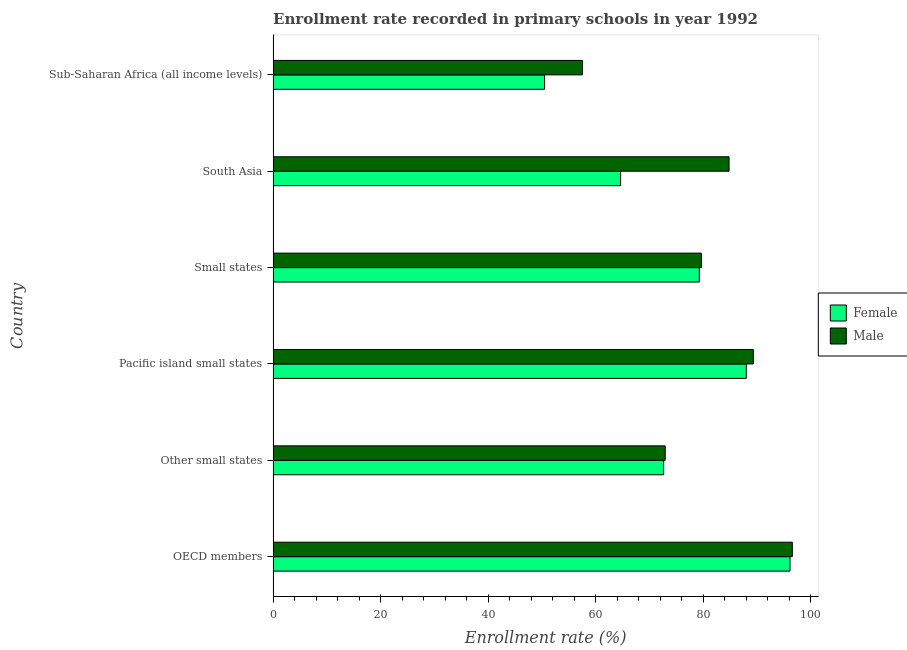How many groups of bars are there?
Your response must be concise. 6. Are the number of bars per tick equal to the number of legend labels?
Keep it short and to the point. Yes. What is the label of the 4th group of bars from the top?
Your answer should be compact. Pacific island small states. In how many cases, is the number of bars for a given country not equal to the number of legend labels?
Give a very brief answer. 0. What is the enrollment rate of female students in Small states?
Offer a terse response. 79.31. Across all countries, what is the maximum enrollment rate of female students?
Your answer should be very brief. 96.19. Across all countries, what is the minimum enrollment rate of female students?
Provide a succinct answer. 50.52. In which country was the enrollment rate of male students minimum?
Ensure brevity in your answer.  Sub-Saharan Africa (all income levels). What is the total enrollment rate of female students in the graph?
Provide a short and direct response. 451.41. What is the difference between the enrollment rate of male students in South Asia and that in Sub-Saharan Africa (all income levels)?
Provide a short and direct response. 27.3. What is the difference between the enrollment rate of female students in Pacific island small states and the enrollment rate of male students in Sub-Saharan Africa (all income levels)?
Your answer should be very brief. 30.5. What is the average enrollment rate of female students per country?
Provide a succinct answer. 75.23. What is the difference between the enrollment rate of female students and enrollment rate of male students in Sub-Saharan Africa (all income levels)?
Provide a succinct answer. -7.03. What is the ratio of the enrollment rate of female students in South Asia to that in Sub-Saharan Africa (all income levels)?
Provide a short and direct response. 1.28. Is the difference between the enrollment rate of male students in OECD members and Small states greater than the difference between the enrollment rate of female students in OECD members and Small states?
Offer a very short reply. Yes. What is the difference between the highest and the second highest enrollment rate of male students?
Make the answer very short. 7.26. What is the difference between the highest and the lowest enrollment rate of male students?
Provide a short and direct response. 39.07. In how many countries, is the enrollment rate of male students greater than the average enrollment rate of male students taken over all countries?
Your answer should be compact. 3. What does the 1st bar from the top in Pacific island small states represents?
Keep it short and to the point. Male. How many bars are there?
Your answer should be very brief. 12. How many countries are there in the graph?
Provide a short and direct response. 6. Are the values on the major ticks of X-axis written in scientific E-notation?
Your answer should be very brief. No. Does the graph contain any zero values?
Offer a very short reply. No. Where does the legend appear in the graph?
Your response must be concise. Center right. How are the legend labels stacked?
Keep it short and to the point. Vertical. What is the title of the graph?
Ensure brevity in your answer.  Enrollment rate recorded in primary schools in year 1992. What is the label or title of the X-axis?
Ensure brevity in your answer.  Enrollment rate (%). What is the Enrollment rate (%) in Female in OECD members?
Your response must be concise. 96.19. What is the Enrollment rate (%) in Male in OECD members?
Your answer should be compact. 96.62. What is the Enrollment rate (%) of Female in Other small states?
Your response must be concise. 72.68. What is the Enrollment rate (%) in Male in Other small states?
Your response must be concise. 72.96. What is the Enrollment rate (%) in Female in Pacific island small states?
Your response must be concise. 88.05. What is the Enrollment rate (%) of Male in Pacific island small states?
Offer a very short reply. 89.36. What is the Enrollment rate (%) in Female in Small states?
Give a very brief answer. 79.31. What is the Enrollment rate (%) of Male in Small states?
Ensure brevity in your answer.  79.7. What is the Enrollment rate (%) in Female in South Asia?
Your response must be concise. 64.66. What is the Enrollment rate (%) of Male in South Asia?
Your answer should be compact. 84.85. What is the Enrollment rate (%) in Female in Sub-Saharan Africa (all income levels)?
Give a very brief answer. 50.52. What is the Enrollment rate (%) of Male in Sub-Saharan Africa (all income levels)?
Ensure brevity in your answer.  57.55. Across all countries, what is the maximum Enrollment rate (%) of Female?
Offer a very short reply. 96.19. Across all countries, what is the maximum Enrollment rate (%) of Male?
Give a very brief answer. 96.62. Across all countries, what is the minimum Enrollment rate (%) of Female?
Offer a terse response. 50.52. Across all countries, what is the minimum Enrollment rate (%) in Male?
Keep it short and to the point. 57.55. What is the total Enrollment rate (%) in Female in the graph?
Offer a terse response. 451.41. What is the total Enrollment rate (%) of Male in the graph?
Provide a short and direct response. 481.04. What is the difference between the Enrollment rate (%) in Female in OECD members and that in Other small states?
Your answer should be very brief. 23.51. What is the difference between the Enrollment rate (%) of Male in OECD members and that in Other small states?
Keep it short and to the point. 23.66. What is the difference between the Enrollment rate (%) in Female in OECD members and that in Pacific island small states?
Ensure brevity in your answer.  8.13. What is the difference between the Enrollment rate (%) in Male in OECD members and that in Pacific island small states?
Give a very brief answer. 7.26. What is the difference between the Enrollment rate (%) in Female in OECD members and that in Small states?
Provide a short and direct response. 16.88. What is the difference between the Enrollment rate (%) of Male in OECD members and that in Small states?
Provide a short and direct response. 16.92. What is the difference between the Enrollment rate (%) in Female in OECD members and that in South Asia?
Give a very brief answer. 31.52. What is the difference between the Enrollment rate (%) in Male in OECD members and that in South Asia?
Offer a very short reply. 11.78. What is the difference between the Enrollment rate (%) in Female in OECD members and that in Sub-Saharan Africa (all income levels)?
Provide a succinct answer. 45.67. What is the difference between the Enrollment rate (%) of Male in OECD members and that in Sub-Saharan Africa (all income levels)?
Your response must be concise. 39.07. What is the difference between the Enrollment rate (%) of Female in Other small states and that in Pacific island small states?
Offer a very short reply. -15.37. What is the difference between the Enrollment rate (%) in Male in Other small states and that in Pacific island small states?
Provide a succinct answer. -16.4. What is the difference between the Enrollment rate (%) in Female in Other small states and that in Small states?
Ensure brevity in your answer.  -6.63. What is the difference between the Enrollment rate (%) of Male in Other small states and that in Small states?
Provide a short and direct response. -6.74. What is the difference between the Enrollment rate (%) in Female in Other small states and that in South Asia?
Offer a terse response. 8.02. What is the difference between the Enrollment rate (%) in Male in Other small states and that in South Asia?
Your answer should be very brief. -11.88. What is the difference between the Enrollment rate (%) in Female in Other small states and that in Sub-Saharan Africa (all income levels)?
Keep it short and to the point. 22.16. What is the difference between the Enrollment rate (%) of Male in Other small states and that in Sub-Saharan Africa (all income levels)?
Your response must be concise. 15.42. What is the difference between the Enrollment rate (%) of Female in Pacific island small states and that in Small states?
Give a very brief answer. 8.75. What is the difference between the Enrollment rate (%) of Male in Pacific island small states and that in Small states?
Provide a short and direct response. 9.66. What is the difference between the Enrollment rate (%) in Female in Pacific island small states and that in South Asia?
Your response must be concise. 23.39. What is the difference between the Enrollment rate (%) of Male in Pacific island small states and that in South Asia?
Your answer should be very brief. 4.52. What is the difference between the Enrollment rate (%) in Female in Pacific island small states and that in Sub-Saharan Africa (all income levels)?
Offer a terse response. 37.54. What is the difference between the Enrollment rate (%) of Male in Pacific island small states and that in Sub-Saharan Africa (all income levels)?
Keep it short and to the point. 31.82. What is the difference between the Enrollment rate (%) of Female in Small states and that in South Asia?
Provide a succinct answer. 14.64. What is the difference between the Enrollment rate (%) of Male in Small states and that in South Asia?
Ensure brevity in your answer.  -5.15. What is the difference between the Enrollment rate (%) in Female in Small states and that in Sub-Saharan Africa (all income levels)?
Your answer should be very brief. 28.79. What is the difference between the Enrollment rate (%) of Male in Small states and that in Sub-Saharan Africa (all income levels)?
Your answer should be compact. 22.15. What is the difference between the Enrollment rate (%) in Female in South Asia and that in Sub-Saharan Africa (all income levels)?
Your response must be concise. 14.15. What is the difference between the Enrollment rate (%) in Male in South Asia and that in Sub-Saharan Africa (all income levels)?
Provide a succinct answer. 27.3. What is the difference between the Enrollment rate (%) in Female in OECD members and the Enrollment rate (%) in Male in Other small states?
Offer a terse response. 23.22. What is the difference between the Enrollment rate (%) in Female in OECD members and the Enrollment rate (%) in Male in Pacific island small states?
Keep it short and to the point. 6.82. What is the difference between the Enrollment rate (%) of Female in OECD members and the Enrollment rate (%) of Male in Small states?
Your response must be concise. 16.49. What is the difference between the Enrollment rate (%) of Female in OECD members and the Enrollment rate (%) of Male in South Asia?
Provide a succinct answer. 11.34. What is the difference between the Enrollment rate (%) in Female in OECD members and the Enrollment rate (%) in Male in Sub-Saharan Africa (all income levels)?
Provide a succinct answer. 38.64. What is the difference between the Enrollment rate (%) in Female in Other small states and the Enrollment rate (%) in Male in Pacific island small states?
Provide a succinct answer. -16.68. What is the difference between the Enrollment rate (%) of Female in Other small states and the Enrollment rate (%) of Male in Small states?
Make the answer very short. -7.02. What is the difference between the Enrollment rate (%) in Female in Other small states and the Enrollment rate (%) in Male in South Asia?
Ensure brevity in your answer.  -12.16. What is the difference between the Enrollment rate (%) in Female in Other small states and the Enrollment rate (%) in Male in Sub-Saharan Africa (all income levels)?
Your answer should be compact. 15.13. What is the difference between the Enrollment rate (%) of Female in Pacific island small states and the Enrollment rate (%) of Male in Small states?
Give a very brief answer. 8.35. What is the difference between the Enrollment rate (%) of Female in Pacific island small states and the Enrollment rate (%) of Male in South Asia?
Your answer should be compact. 3.21. What is the difference between the Enrollment rate (%) of Female in Pacific island small states and the Enrollment rate (%) of Male in Sub-Saharan Africa (all income levels)?
Provide a short and direct response. 30.5. What is the difference between the Enrollment rate (%) in Female in Small states and the Enrollment rate (%) in Male in South Asia?
Offer a terse response. -5.54. What is the difference between the Enrollment rate (%) in Female in Small states and the Enrollment rate (%) in Male in Sub-Saharan Africa (all income levels)?
Make the answer very short. 21.76. What is the difference between the Enrollment rate (%) in Female in South Asia and the Enrollment rate (%) in Male in Sub-Saharan Africa (all income levels)?
Provide a succinct answer. 7.12. What is the average Enrollment rate (%) in Female per country?
Make the answer very short. 75.23. What is the average Enrollment rate (%) in Male per country?
Offer a very short reply. 80.17. What is the difference between the Enrollment rate (%) in Female and Enrollment rate (%) in Male in OECD members?
Make the answer very short. -0.43. What is the difference between the Enrollment rate (%) in Female and Enrollment rate (%) in Male in Other small states?
Your response must be concise. -0.28. What is the difference between the Enrollment rate (%) in Female and Enrollment rate (%) in Male in Pacific island small states?
Your answer should be compact. -1.31. What is the difference between the Enrollment rate (%) of Female and Enrollment rate (%) of Male in Small states?
Keep it short and to the point. -0.39. What is the difference between the Enrollment rate (%) in Female and Enrollment rate (%) in Male in South Asia?
Your answer should be compact. -20.18. What is the difference between the Enrollment rate (%) in Female and Enrollment rate (%) in Male in Sub-Saharan Africa (all income levels)?
Your answer should be compact. -7.03. What is the ratio of the Enrollment rate (%) in Female in OECD members to that in Other small states?
Offer a very short reply. 1.32. What is the ratio of the Enrollment rate (%) in Male in OECD members to that in Other small states?
Offer a terse response. 1.32. What is the ratio of the Enrollment rate (%) of Female in OECD members to that in Pacific island small states?
Ensure brevity in your answer.  1.09. What is the ratio of the Enrollment rate (%) of Male in OECD members to that in Pacific island small states?
Your response must be concise. 1.08. What is the ratio of the Enrollment rate (%) of Female in OECD members to that in Small states?
Give a very brief answer. 1.21. What is the ratio of the Enrollment rate (%) of Male in OECD members to that in Small states?
Offer a very short reply. 1.21. What is the ratio of the Enrollment rate (%) in Female in OECD members to that in South Asia?
Provide a short and direct response. 1.49. What is the ratio of the Enrollment rate (%) in Male in OECD members to that in South Asia?
Give a very brief answer. 1.14. What is the ratio of the Enrollment rate (%) in Female in OECD members to that in Sub-Saharan Africa (all income levels)?
Provide a succinct answer. 1.9. What is the ratio of the Enrollment rate (%) in Male in OECD members to that in Sub-Saharan Africa (all income levels)?
Offer a very short reply. 1.68. What is the ratio of the Enrollment rate (%) of Female in Other small states to that in Pacific island small states?
Provide a short and direct response. 0.83. What is the ratio of the Enrollment rate (%) in Male in Other small states to that in Pacific island small states?
Your answer should be compact. 0.82. What is the ratio of the Enrollment rate (%) of Female in Other small states to that in Small states?
Your answer should be compact. 0.92. What is the ratio of the Enrollment rate (%) in Male in Other small states to that in Small states?
Your answer should be very brief. 0.92. What is the ratio of the Enrollment rate (%) of Female in Other small states to that in South Asia?
Give a very brief answer. 1.12. What is the ratio of the Enrollment rate (%) of Male in Other small states to that in South Asia?
Provide a succinct answer. 0.86. What is the ratio of the Enrollment rate (%) in Female in Other small states to that in Sub-Saharan Africa (all income levels)?
Offer a very short reply. 1.44. What is the ratio of the Enrollment rate (%) of Male in Other small states to that in Sub-Saharan Africa (all income levels)?
Keep it short and to the point. 1.27. What is the ratio of the Enrollment rate (%) of Female in Pacific island small states to that in Small states?
Provide a succinct answer. 1.11. What is the ratio of the Enrollment rate (%) of Male in Pacific island small states to that in Small states?
Provide a short and direct response. 1.12. What is the ratio of the Enrollment rate (%) of Female in Pacific island small states to that in South Asia?
Offer a very short reply. 1.36. What is the ratio of the Enrollment rate (%) of Male in Pacific island small states to that in South Asia?
Offer a very short reply. 1.05. What is the ratio of the Enrollment rate (%) of Female in Pacific island small states to that in Sub-Saharan Africa (all income levels)?
Offer a terse response. 1.74. What is the ratio of the Enrollment rate (%) of Male in Pacific island small states to that in Sub-Saharan Africa (all income levels)?
Ensure brevity in your answer.  1.55. What is the ratio of the Enrollment rate (%) of Female in Small states to that in South Asia?
Your response must be concise. 1.23. What is the ratio of the Enrollment rate (%) in Male in Small states to that in South Asia?
Make the answer very short. 0.94. What is the ratio of the Enrollment rate (%) in Female in Small states to that in Sub-Saharan Africa (all income levels)?
Provide a succinct answer. 1.57. What is the ratio of the Enrollment rate (%) in Male in Small states to that in Sub-Saharan Africa (all income levels)?
Offer a terse response. 1.38. What is the ratio of the Enrollment rate (%) in Female in South Asia to that in Sub-Saharan Africa (all income levels)?
Your answer should be very brief. 1.28. What is the ratio of the Enrollment rate (%) in Male in South Asia to that in Sub-Saharan Africa (all income levels)?
Your answer should be very brief. 1.47. What is the difference between the highest and the second highest Enrollment rate (%) in Female?
Make the answer very short. 8.13. What is the difference between the highest and the second highest Enrollment rate (%) in Male?
Give a very brief answer. 7.26. What is the difference between the highest and the lowest Enrollment rate (%) of Female?
Make the answer very short. 45.67. What is the difference between the highest and the lowest Enrollment rate (%) of Male?
Provide a succinct answer. 39.07. 